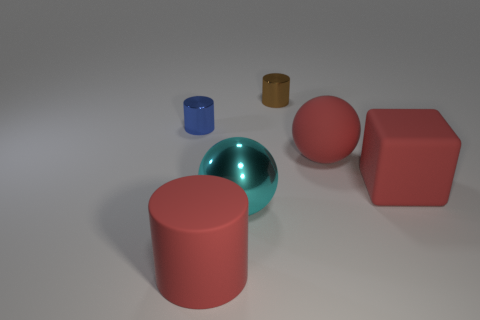Is the material of the big red thing that is in front of the big block the same as the thing behind the blue object?
Give a very brief answer. No. What is the size of the cylinder in front of the small metallic cylinder that is in front of the tiny brown shiny cylinder?
Offer a very short reply. Large. What is the material of the large red object on the left side of the brown metallic cylinder?
Provide a short and direct response. Rubber. How many things are either big matte things behind the large red matte cylinder or metallic things in front of the tiny brown metal object?
Offer a terse response. 4. What is the material of the other thing that is the same shape as the big cyan shiny thing?
Keep it short and to the point. Rubber. Does the big sphere to the right of the brown object have the same color as the large block that is on the right side of the red rubber cylinder?
Keep it short and to the point. Yes. Are there any rubber objects of the same size as the cyan metallic thing?
Your answer should be very brief. Yes. There is a thing that is both to the left of the large cyan ball and in front of the big red cube; what is it made of?
Your answer should be very brief. Rubber. What number of matte things are either large objects or big yellow blocks?
Your answer should be compact. 3. There is a big cyan object that is made of the same material as the tiny brown thing; what is its shape?
Your answer should be very brief. Sphere. 